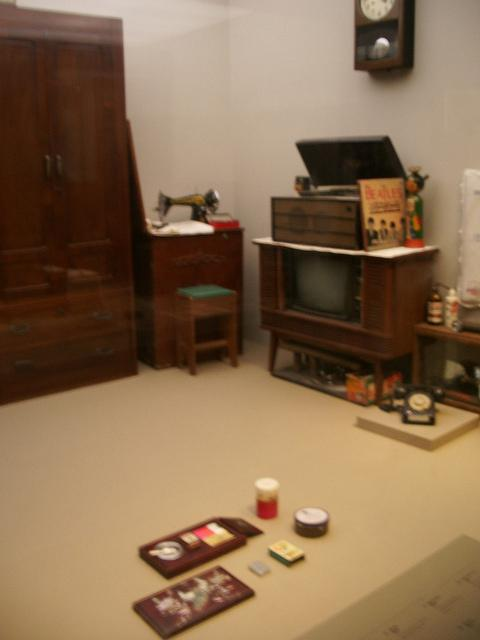What is able to be repaired by the machine in the corner?

Choices:
A) tv
B) ovens
C) clothing
D) shoes clothing 